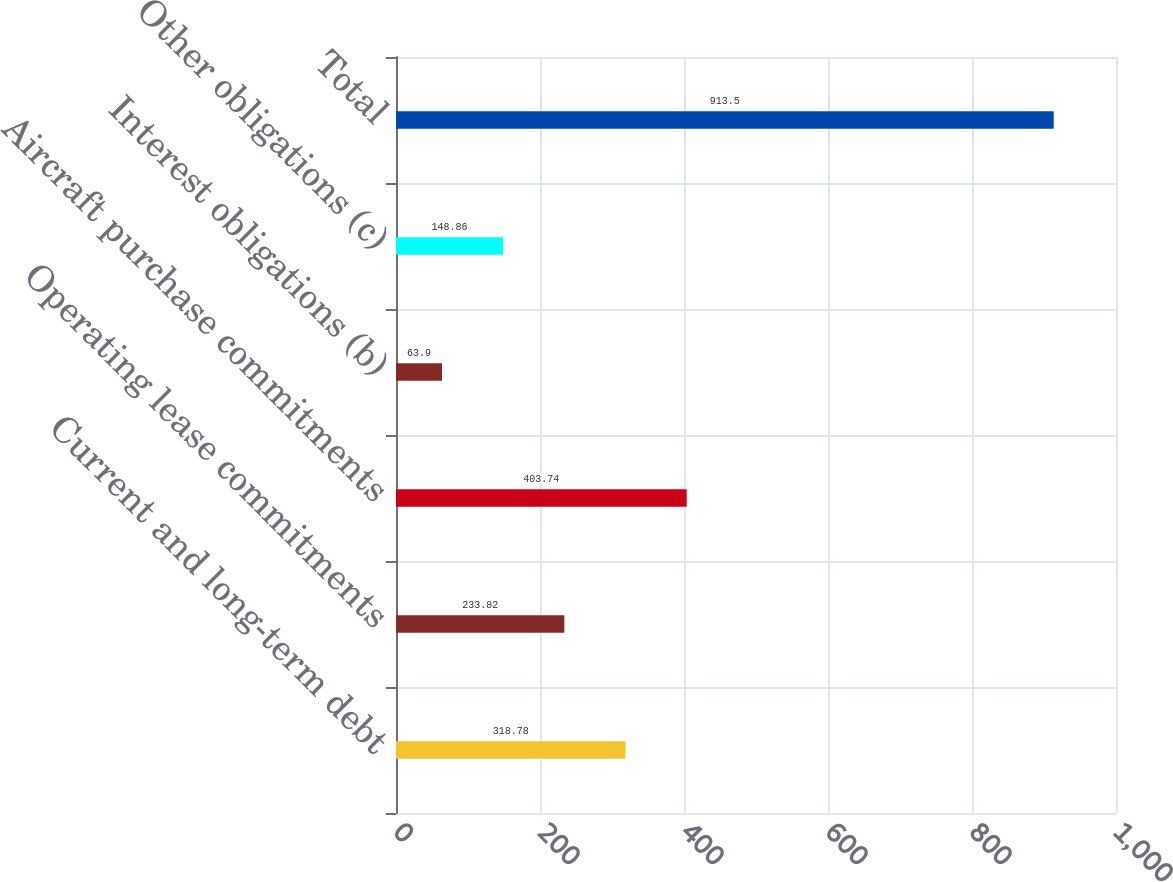Convert chart. <chart><loc_0><loc_0><loc_500><loc_500><bar_chart><fcel>Current and long-term debt<fcel>Operating lease commitments<fcel>Aircraft purchase commitments<fcel>Interest obligations (b)<fcel>Other obligations (c)<fcel>Total<nl><fcel>318.78<fcel>233.82<fcel>403.74<fcel>63.9<fcel>148.86<fcel>913.5<nl></chart> 